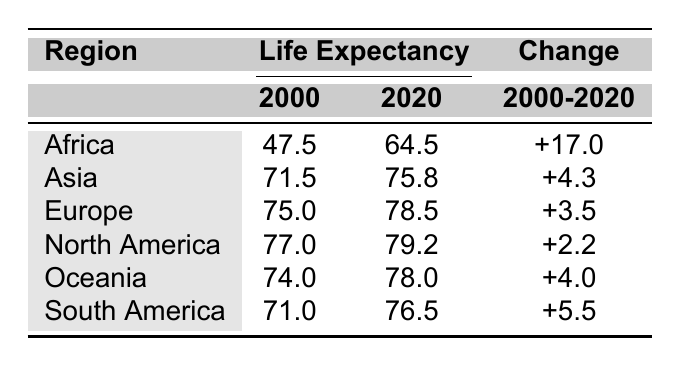What was the life expectancy in North America in 2000? According to the table, the life expectancy in North America for the year 2000 is listed as 77.0.
Answer: 77.0 Which region saw the largest increase in life expectancy from 2000 to 2020? By comparing the changes in life expectancy across regions, Africa increased from 47.5 to 64.5, resulting in an increase of 17.0, which is the largest among all regions.
Answer: Africa What was the life expectancy in Oceania in 2020? According to the table, Oceania's life expectancy in 2020 is shown as 78.0.
Answer: 78.0 Is it true that Asia had a higher life expectancy than South America in 2020? In the year 2020, Asia's life expectancy is 75.8 while South America's is 76.5. Since 76.5 is greater than 75.8, the statement is false.
Answer: No What is the total life expectancy change for Europe and North America combined from 2000 to 2020? The change for Europe is +3.5 and for North America is +2.2. Adding these together gives 3.5 + 2.2 = 5.7, which is their total life expectancy change combined.
Answer: 5.7 What was the average life expectancy in Africa and Asia in 2020? The life expectancies in 2020 for Africa and Asia are 64.5 and 75.8 respectively. To find the average, sum these two values (64.5 + 75.8 = 140.3) and divide by 2, which gives an average of 140.3 / 2 = 70.15.
Answer: 70.15 Which regions had a life expectancy of over 75 in 2020? From the table, the regions with life expectancy over 75 in 2020 are Europe (78.5), North America (79.2), and Oceania (78.0).
Answer: Europe, North America, Oceania What is the difference in life expectancy in South America between 2000 and 2020? South America's life expectancy in 2000 is 71.0 and in 2020 is 76.5. The difference is calculated as 76.5 - 71.0 = 5.5.
Answer: 5.5 